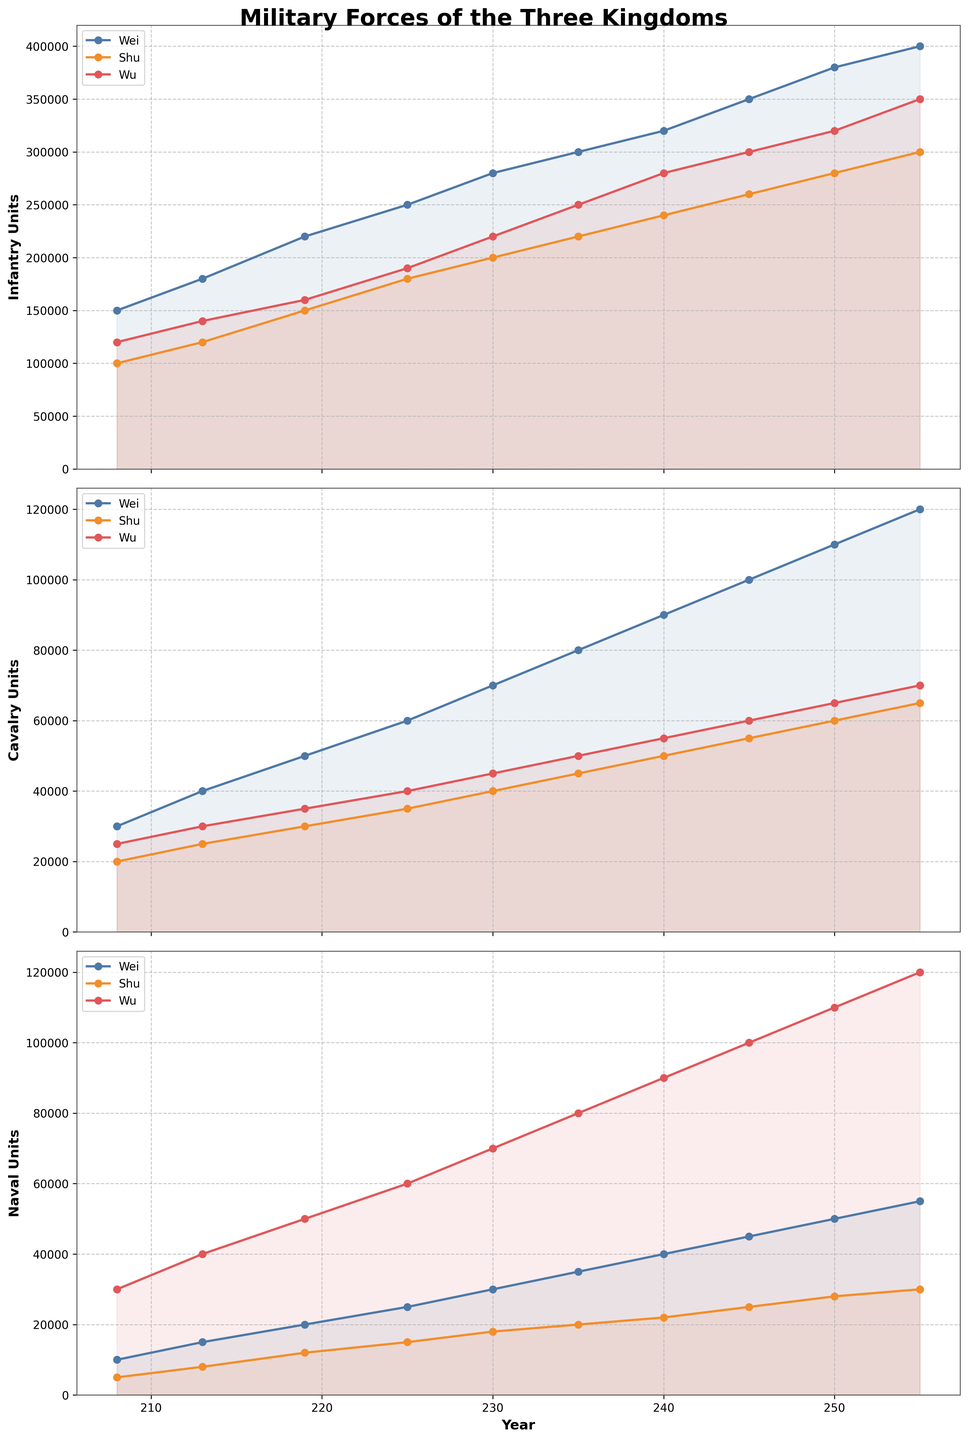What year did the Wei kingdom have its first noticeable increase in infantry units? From the line chart for Wei's infantry units, the graph consistently rises over time. The first noticeable increase in Wei infantry units occurs from 213 to 219.
Answer: 213 Which kingdom had the highest number of naval units in 250? By examining the lines corresponding to the naval units for each kingdom at the year 250, Wu's naval units have the highest point on the graph.
Answer: Wu Comparing years 213 and 230, which kingdom had the greater increase in cavalry units? To find which kingdom had the greater increase, subtract each kingdom's cavalry units in 213 from its cavalry units in 230. For Wei: 70000 - 40000 = 30000. For Shu: 40000 - 25000 = 15000. For Wu: 45000 - 30000 = 15000. Wei had the largest increase.
Answer: Wei What is the total number of Shu's military units in 240? Sum the infantry, cavalry, and naval units for Shu in 240: 240000 (infantry) + 50000 (cavalry) + 22000 (naval) = 312000.
Answer: 312000 Which kingdom had the smallest number of cavalry units in 208, and how does its amount compare to Wu's cavalry units in the same year? In 208, the smallest number of cavalry units is Shu with 20000. Wu had 25000 cavalry units in 208, which means Wu had 5000 more cavalry than Shu.
Answer: Shu, 5000 more Based on the plot for 225, which kingdom's infantry force is closest to the sum of the other two kingdoms' naval units for the same year? Calculate the sum of Shu and Wu's naval units in 225: 15000 (Shu) + 60000 (Wu) = 75000. Compare this with each kingdom's infantry force. Wei's infantry force in 225 is 250000, Shu's is 180000, and Wu's is 190000. The infantry number closest to 75000 is Shu's infantry force of 180000.
Answer: Shu In which year did Shu's naval units first surpass 20000? Identify the year where Shu's naval units first go above 20000 by tracing the Shu naval line. This occurs in 235.
Answer: 235 Which kingdom had the least number of infantry units in 255 and by how much did it differ from Wei's cavalry units in the same year? From the graph for 255, Shu had the least number of infantry units at 300000. Wei’s cavalry units in 255 were 120000. The difference between these numbers is 300000 - 120000 = 180000.
Answer: Shu, 180000 Between Wei and Wu, which kingdom showed a larger relative increase in naval units from 219 to 245? Calculate the relative increase for each. Wei: (45000 - 20000) / 20000 = 1.25 (125%). Wu: (100000 - 50000) / 50000 = 1 (100%). Wei had a larger relative increase.
Answer: Wei 